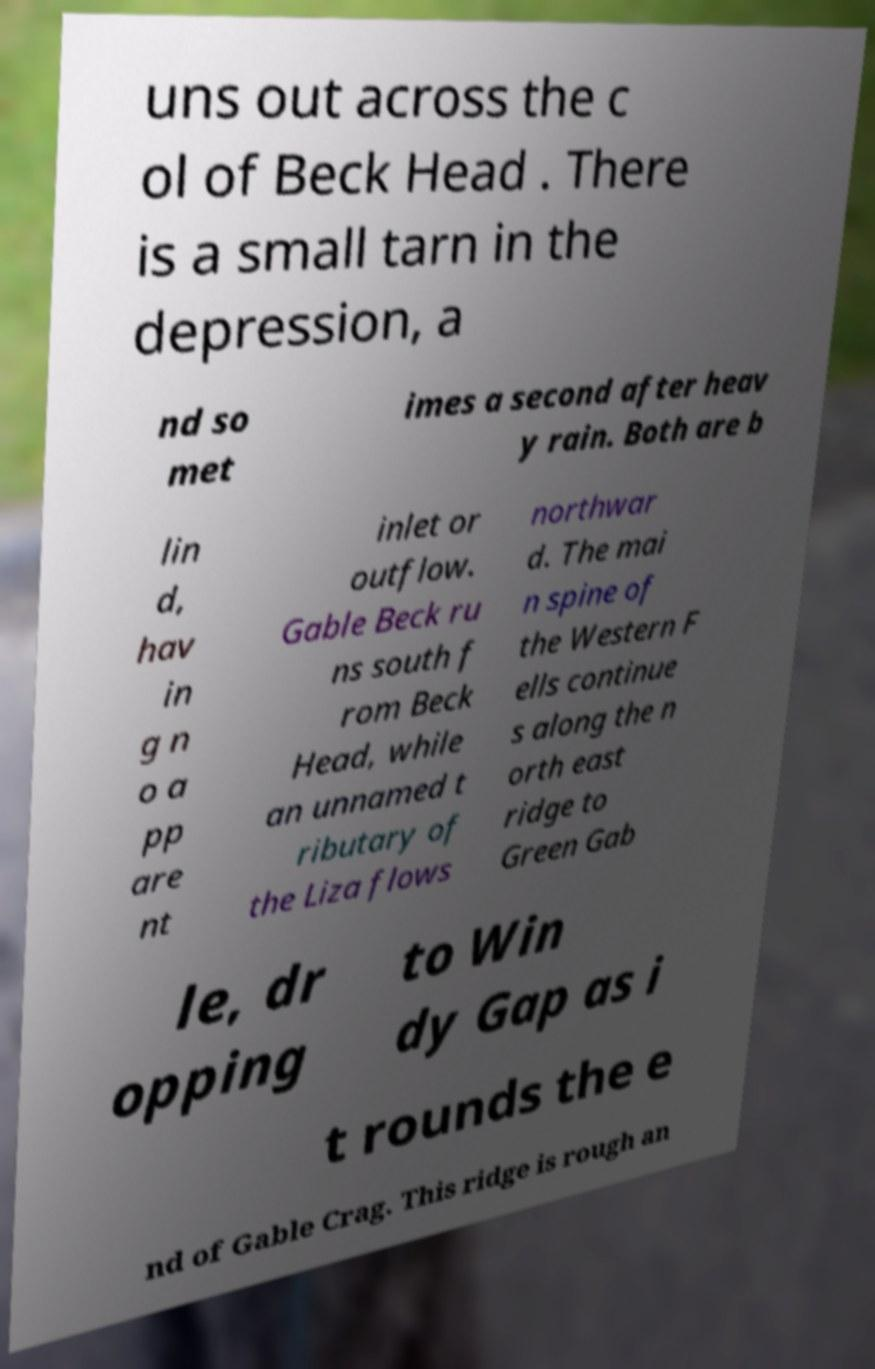There's text embedded in this image that I need extracted. Can you transcribe it verbatim? uns out across the c ol of Beck Head . There is a small tarn in the depression, a nd so met imes a second after heav y rain. Both are b lin d, hav in g n o a pp are nt inlet or outflow. Gable Beck ru ns south f rom Beck Head, while an unnamed t ributary of the Liza flows northwar d. The mai n spine of the Western F ells continue s along the n orth east ridge to Green Gab le, dr opping to Win dy Gap as i t rounds the e nd of Gable Crag. This ridge is rough an 